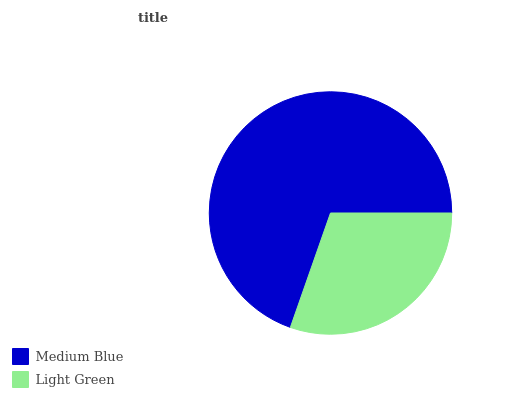Is Light Green the minimum?
Answer yes or no. Yes. Is Medium Blue the maximum?
Answer yes or no. Yes. Is Light Green the maximum?
Answer yes or no. No. Is Medium Blue greater than Light Green?
Answer yes or no. Yes. Is Light Green less than Medium Blue?
Answer yes or no. Yes. Is Light Green greater than Medium Blue?
Answer yes or no. No. Is Medium Blue less than Light Green?
Answer yes or no. No. Is Medium Blue the high median?
Answer yes or no. Yes. Is Light Green the low median?
Answer yes or no. Yes. Is Light Green the high median?
Answer yes or no. No. Is Medium Blue the low median?
Answer yes or no. No. 